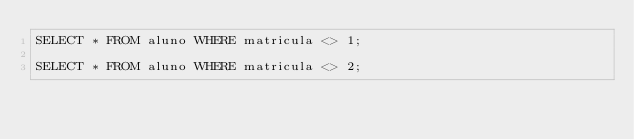Convert code to text. <code><loc_0><loc_0><loc_500><loc_500><_SQL_>SELECT * FROM aluno WHERE matricula <> 1;

SELECT * FROM aluno WHERE matricula <> 2;</code> 